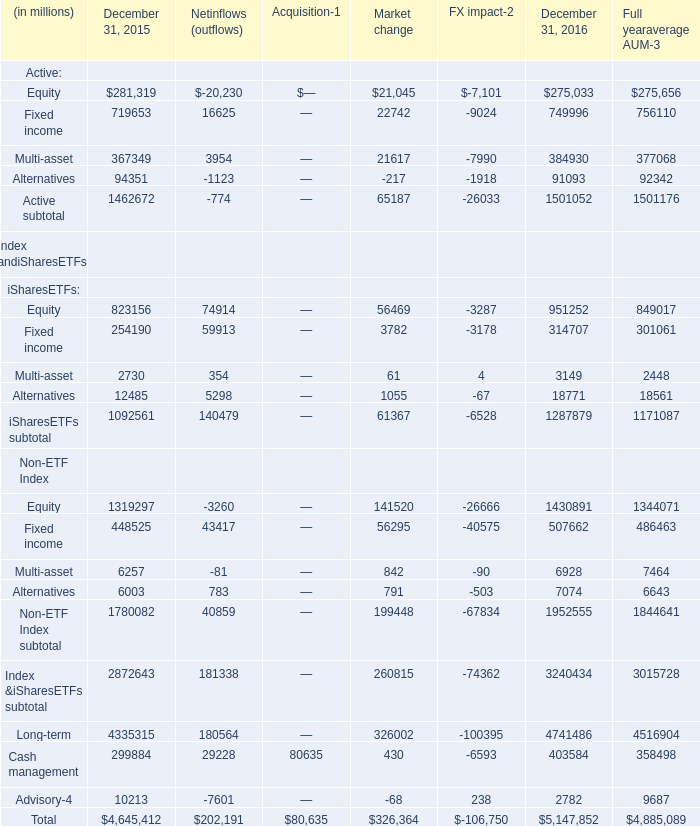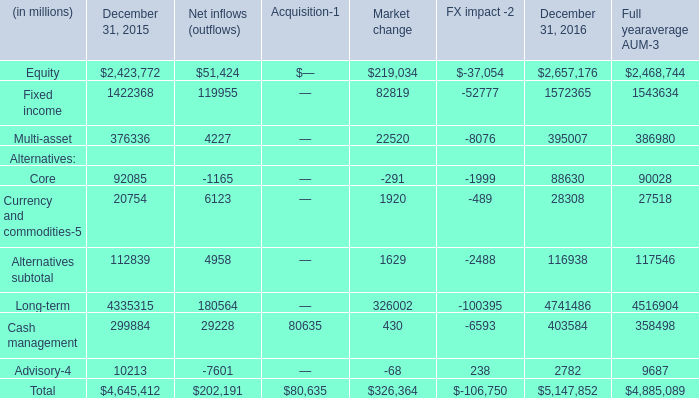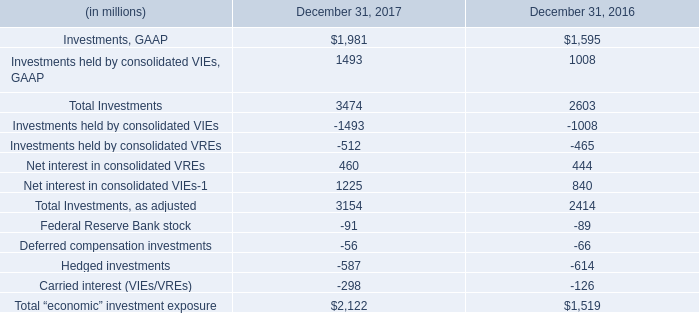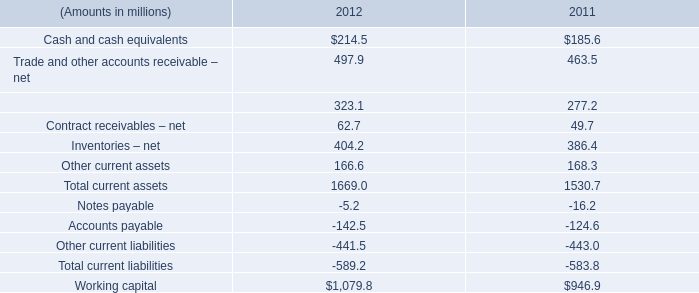In the year with largest amount of currency and commodities , what's the increasing rate of long-term alternatives? 
Computations: ((4741486 - 4335315) / 4335315)
Answer: 0.09369. 